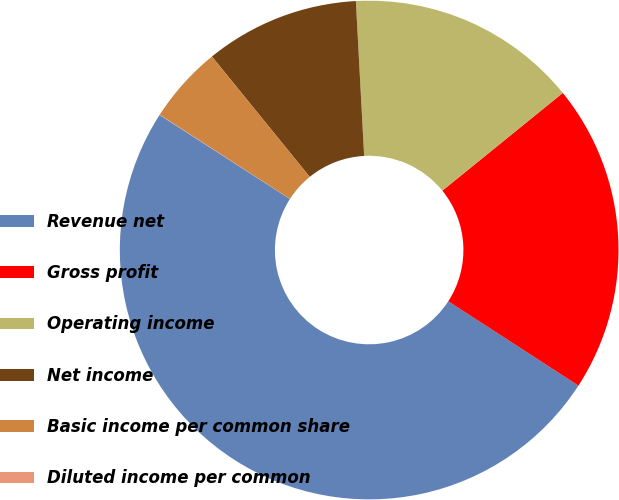<chart> <loc_0><loc_0><loc_500><loc_500><pie_chart><fcel>Revenue net<fcel>Gross profit<fcel>Operating income<fcel>Net income<fcel>Basic income per common share<fcel>Diluted income per common<nl><fcel>49.96%<fcel>20.0%<fcel>15.0%<fcel>10.01%<fcel>5.01%<fcel>0.02%<nl></chart> 